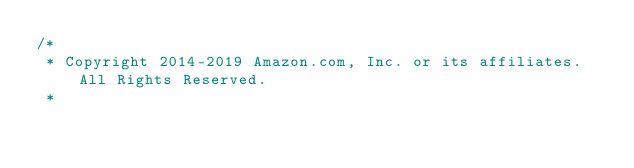<code> <loc_0><loc_0><loc_500><loc_500><_Java_>/*
 * Copyright 2014-2019 Amazon.com, Inc. or its affiliates. All Rights Reserved.
 * </code> 